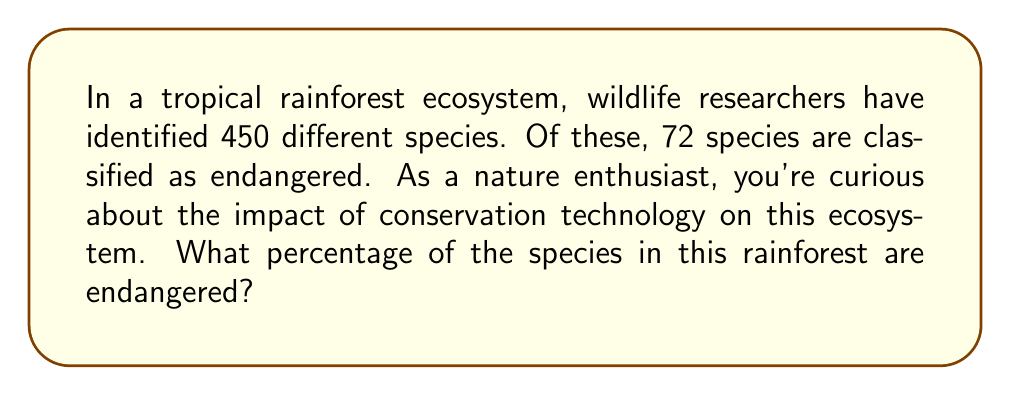Provide a solution to this math problem. To solve this problem, we need to follow these steps:

1. Identify the total number of species:
   Total species = 450

2. Identify the number of endangered species:
   Endangered species = 72

3. Calculate the percentage using the formula:
   $$ \text{Percentage} = \frac{\text{Part}}{\text{Whole}} \times 100\% $$

4. Substitute the values into the formula:
   $$ \text{Percentage of endangered species} = \frac{72}{450} \times 100\% $$

5. Simplify the fraction:
   $$ \frac{72}{450} = \frac{8}{50} = 0.16 $$

6. Multiply by 100% to get the final percentage:
   $$ 0.16 \times 100\% = 16\% $$

Therefore, 16% of the species in this rainforest ecosystem are endangered.
Answer: 16% 